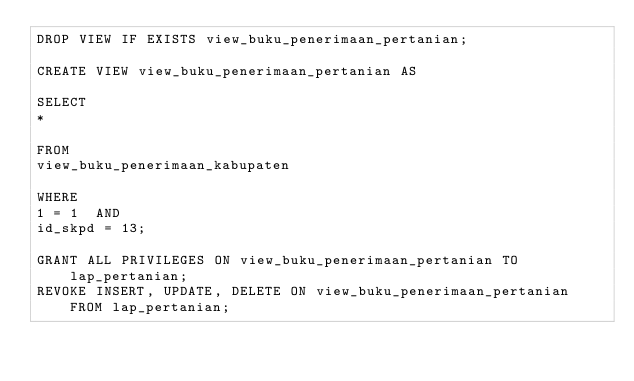Convert code to text. <code><loc_0><loc_0><loc_500><loc_500><_SQL_>DROP VIEW IF EXISTS view_buku_penerimaan_pertanian;

CREATE VIEW view_buku_penerimaan_pertanian AS

SELECT
*

FROM
view_buku_penerimaan_kabupaten

WHERE
1 = 1  AND
id_skpd = 13;

GRANT ALL PRIVILEGES ON view_buku_penerimaan_pertanian TO lap_pertanian;
REVOKE INSERT, UPDATE, DELETE ON view_buku_penerimaan_pertanian FROM lap_pertanian;
</code> 